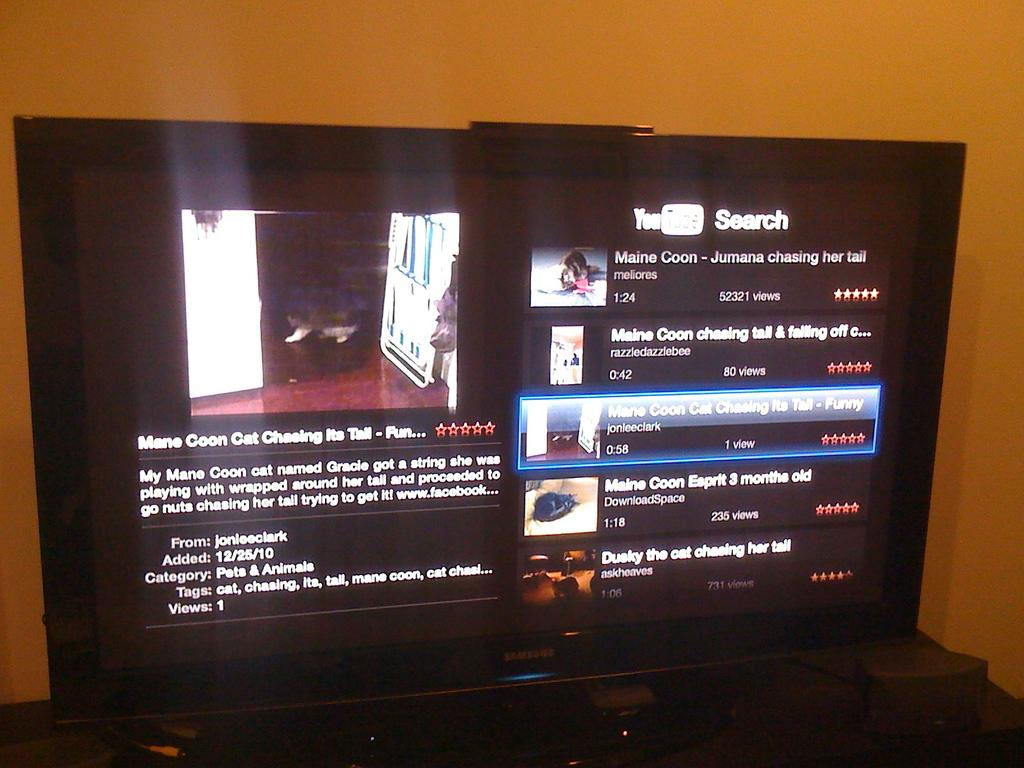Provide a one-sentence caption for the provided image. A collection of YouTube videos display search results relating to Maine Coon cats. 